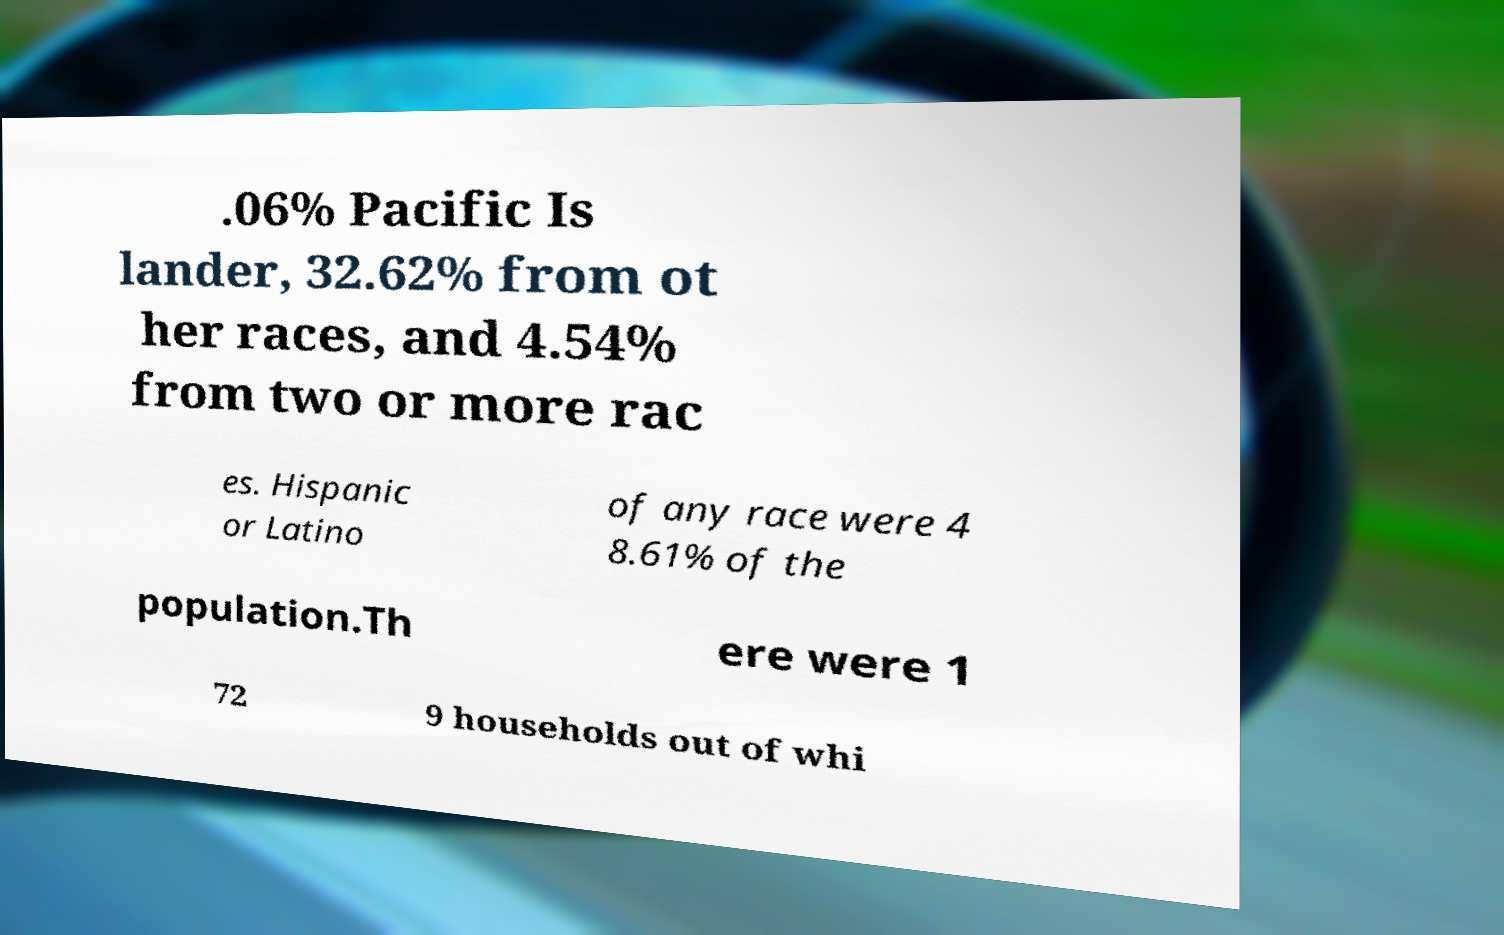Can you accurately transcribe the text from the provided image for me? .06% Pacific Is lander, 32.62% from ot her races, and 4.54% from two or more rac es. Hispanic or Latino of any race were 4 8.61% of the population.Th ere were 1 72 9 households out of whi 